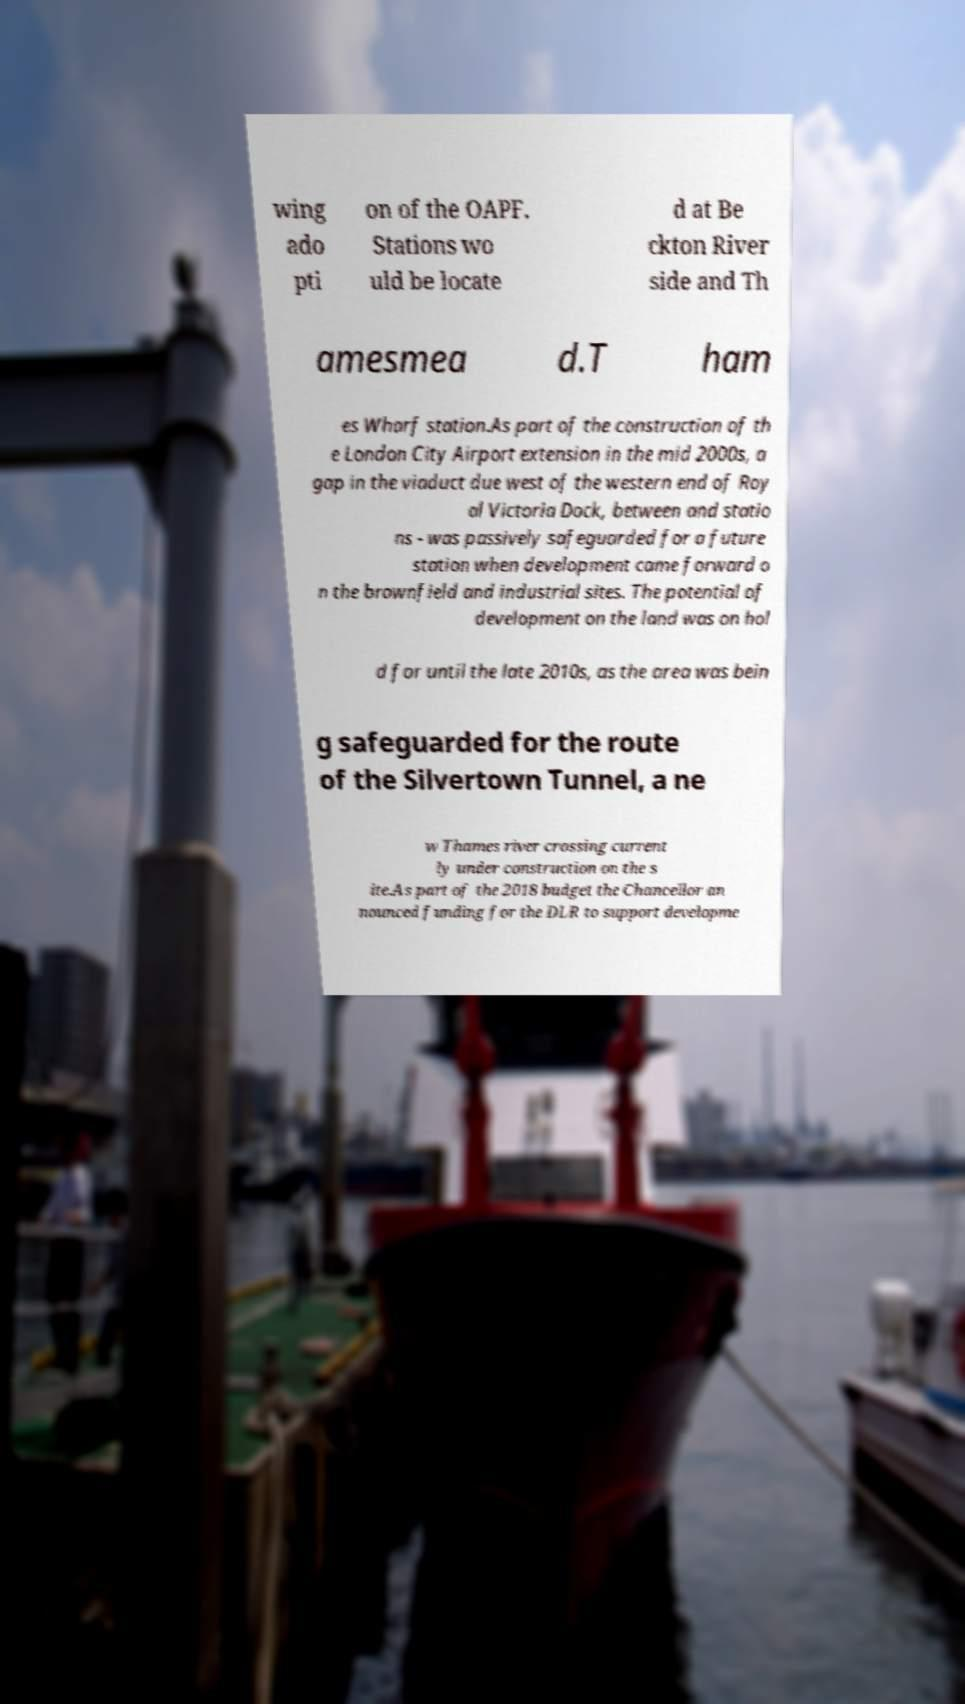There's text embedded in this image that I need extracted. Can you transcribe it verbatim? wing ado pti on of the OAPF. Stations wo uld be locate d at Be ckton River side and Th amesmea d.T ham es Wharf station.As part of the construction of th e London City Airport extension in the mid 2000s, a gap in the viaduct due west of the western end of Roy al Victoria Dock, between and statio ns - was passively safeguarded for a future station when development came forward o n the brownfield and industrial sites. The potential of development on the land was on hol d for until the late 2010s, as the area was bein g safeguarded for the route of the Silvertown Tunnel, a ne w Thames river crossing current ly under construction on the s ite.As part of the 2018 budget the Chancellor an nounced funding for the DLR to support developme 